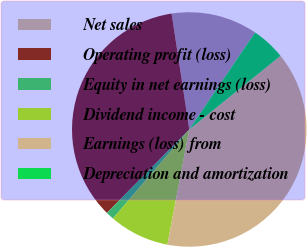Convert chart. <chart><loc_0><loc_0><loc_500><loc_500><pie_chart><fcel>Net sales<fcel>Operating profit (loss)<fcel>Equity in net earnings (loss)<fcel>Dividend income - cost<fcel>Earnings (loss) from<fcel>Depreciation and amortization<nl><fcel>11.89%<fcel>35.2%<fcel>1.11%<fcel>8.3%<fcel>38.79%<fcel>4.71%<nl></chart> 